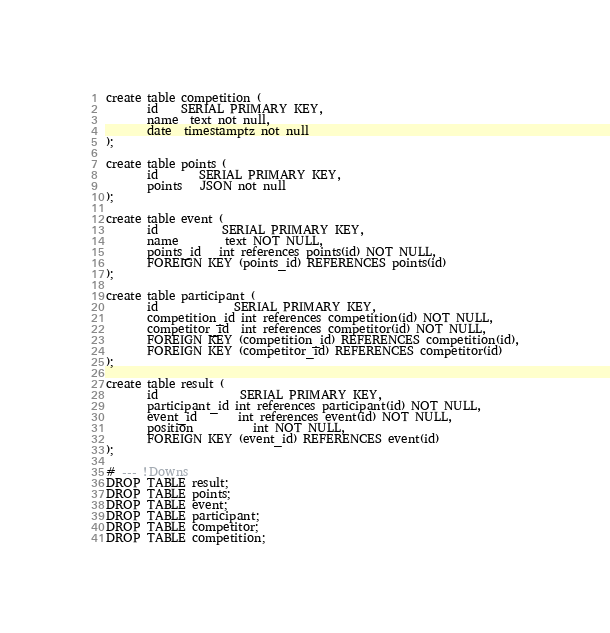<code> <loc_0><loc_0><loc_500><loc_500><_SQL_>create table competition (
       id    SERIAL PRIMARY KEY,
       name  text not null,
       date  timestamptz not null
);

create table points (
       id       SERIAL PRIMARY KEY,
       points   JSON not null
);

create table event (
       id    	   SERIAL PRIMARY KEY,
       name        text NOT NULL,
       points_id   int references points(id) NOT NULL,
       FOREIGN KEY (points_id) REFERENCES points(id)
);

create table participant (
       id             SERIAL PRIMARY KEY,
       competition_id int references competition(id) NOT NULL,
       competitor_id  int references competitor(id) NOT NULL,
       FOREIGN KEY (competition_id) REFERENCES competition(id),
       FOREIGN KEY (competitor_id) REFERENCES competitor(id)
);

create table result (
       id    	      SERIAL PRIMARY KEY,
       participant_id int references participant(id) NOT NULL,
       event_id       int references event(id) NOT NULL,
       position	      int NOT NULL,
       FOREIGN KEY (event_id) REFERENCES event(id)
);

# --- !Downs
DROP TABLE result;
DROP TABLE points;
DROP TABLE event;
DROP TABLE participant;
DROP TABLE competitor;
DROP TABLE competition;
</code> 